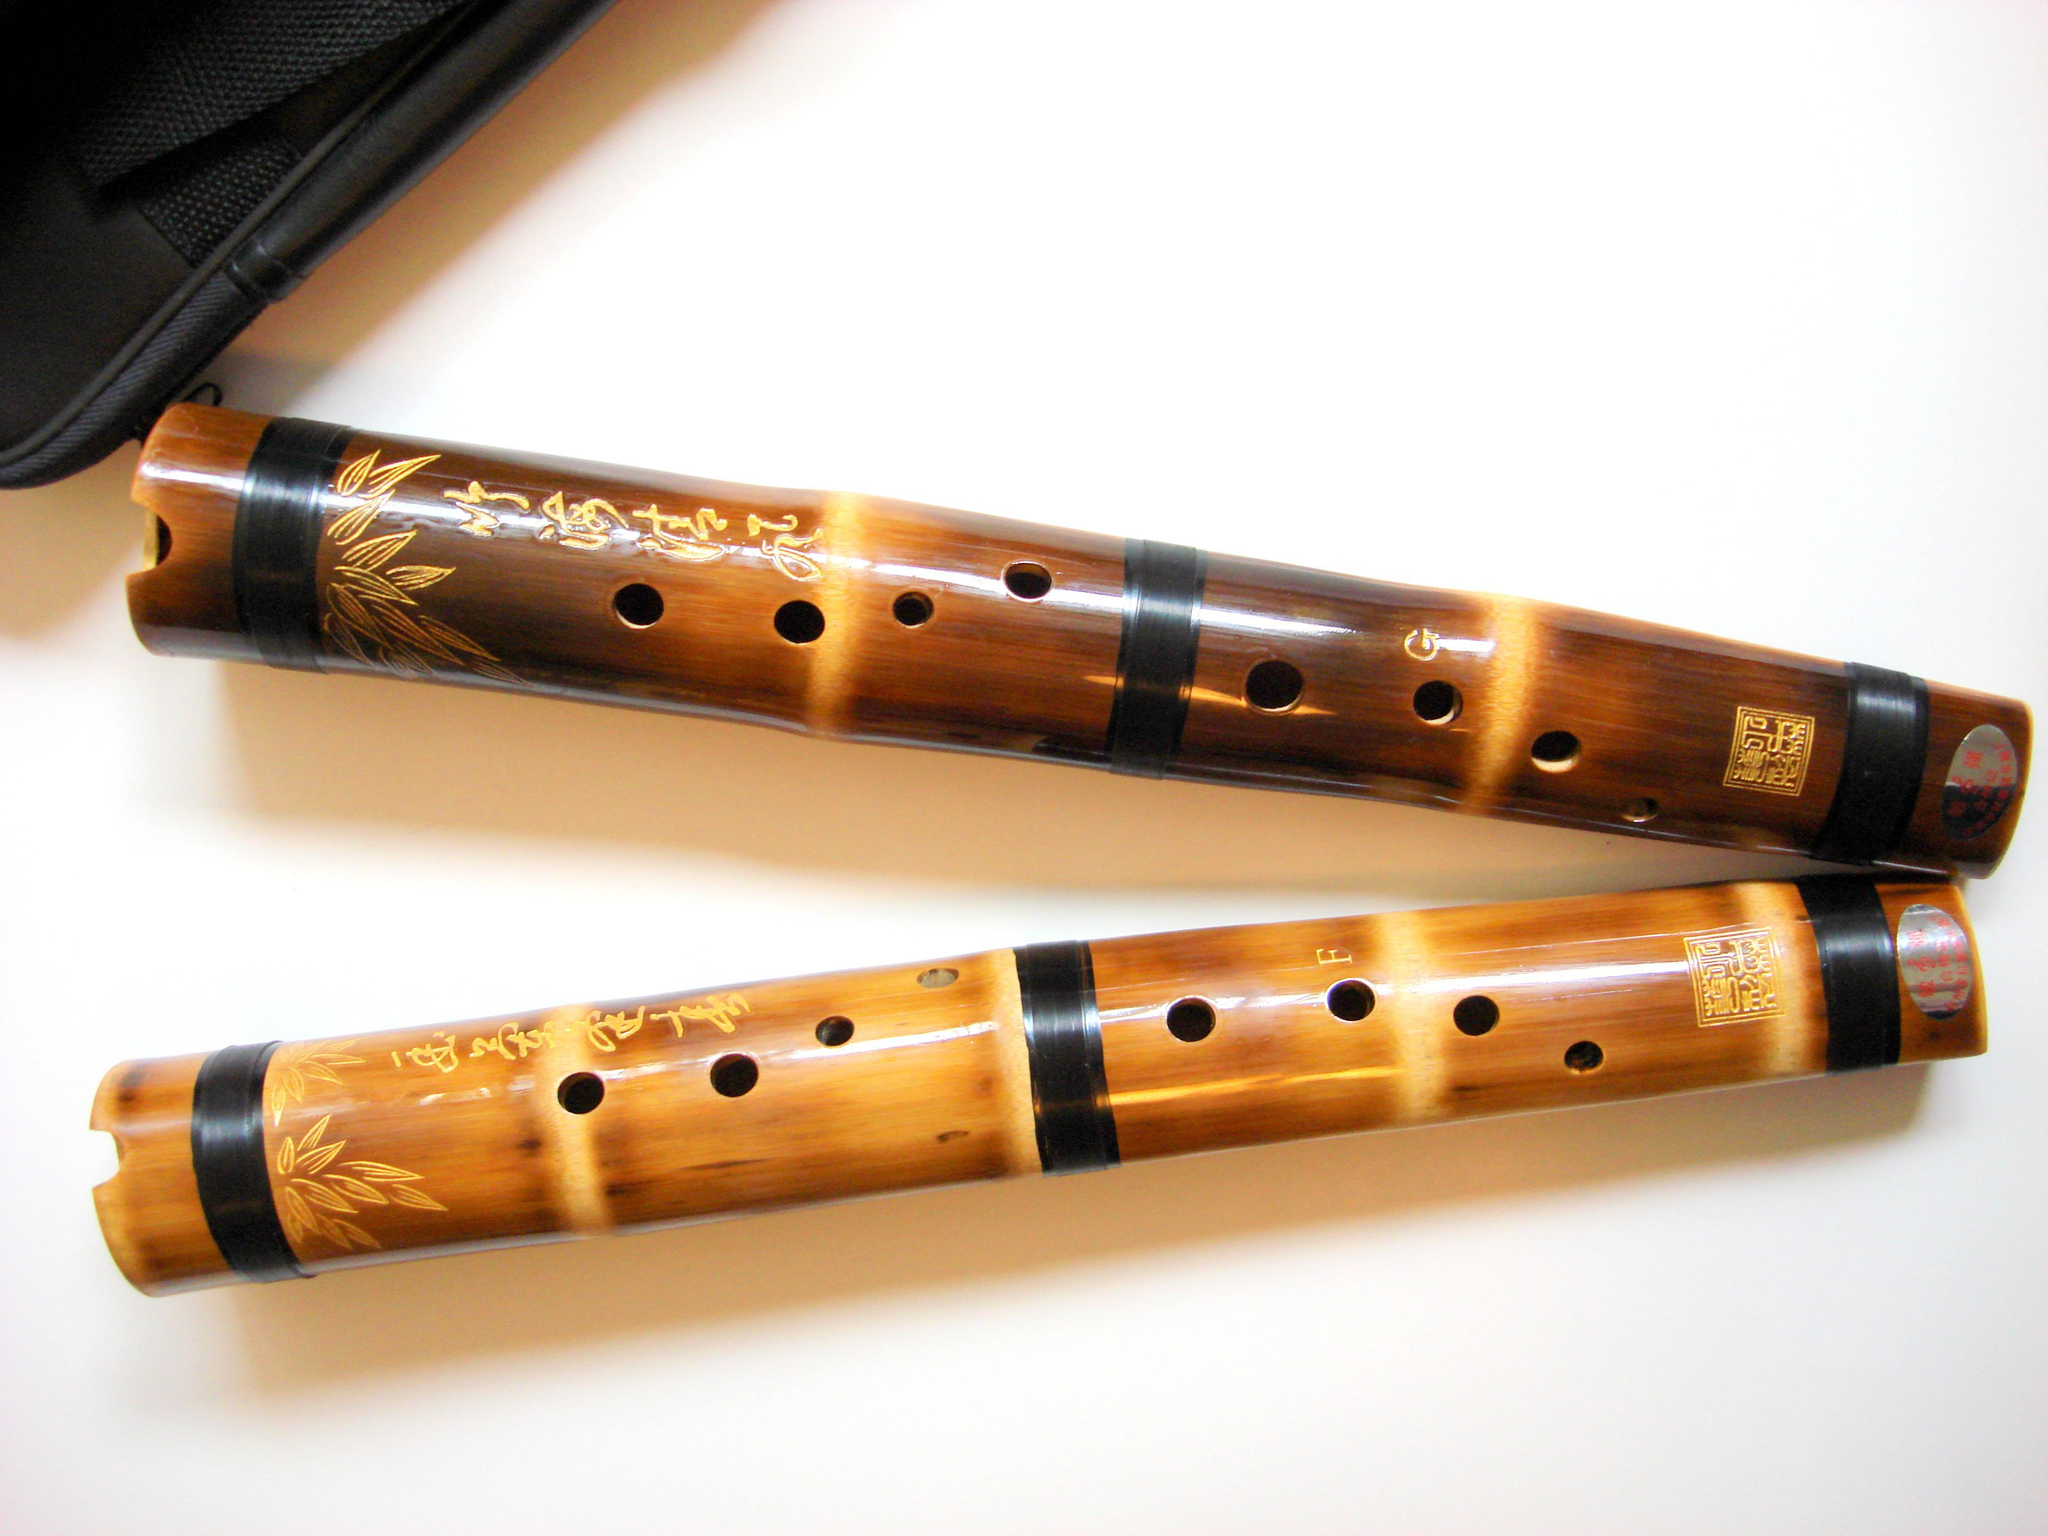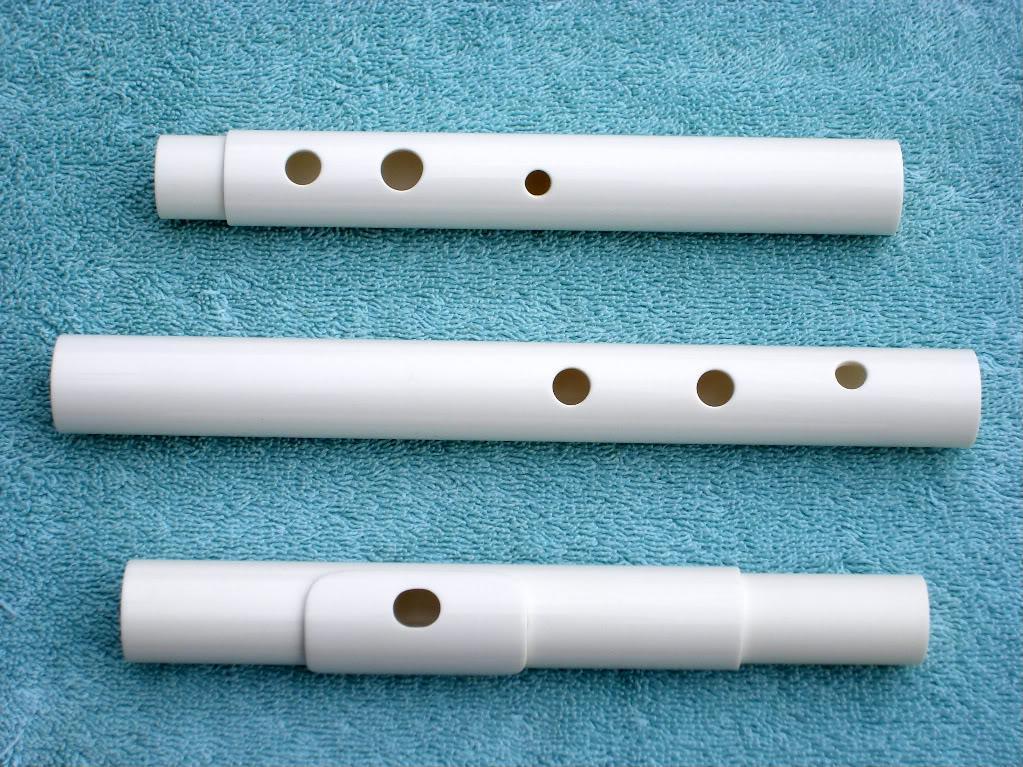The first image is the image on the left, the second image is the image on the right. Assess this claim about the two images: "The combined images contain exactly 5 pipe shapes with at least one flat end, and the images include at least one pipe shape perforated with holes on its side.". Correct or not? Answer yes or no. Yes. 